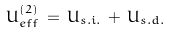Convert formula to latex. <formula><loc_0><loc_0><loc_500><loc_500>U _ { e f f } ^ { ( 2 ) } \, = \, U _ { s . i . } \, + \, U _ { s . d . }</formula> 